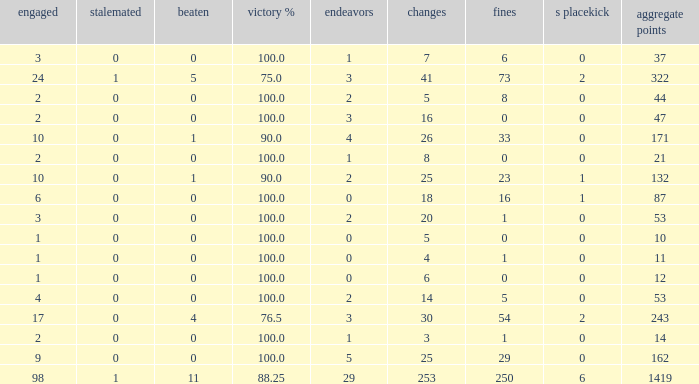How many ties did he have when he had 1 penalties and more than 20 conversions? None. 